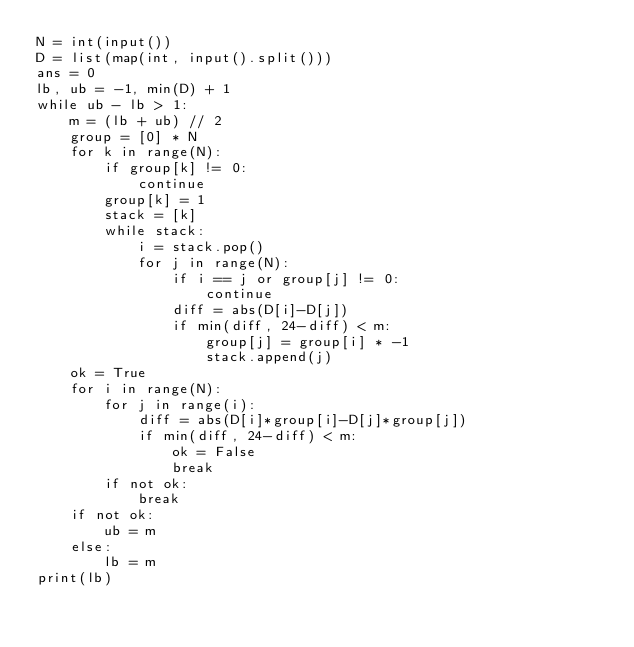<code> <loc_0><loc_0><loc_500><loc_500><_Python_>N = int(input())
D = list(map(int, input().split()))
ans = 0
lb, ub = -1, min(D) + 1
while ub - lb > 1:
    m = (lb + ub) // 2
    group = [0] * N
    for k in range(N):
        if group[k] != 0:
            continue
        group[k] = 1
        stack = [k]
        while stack:
            i = stack.pop()
            for j in range(N):
                if i == j or group[j] != 0:
                    continue
                diff = abs(D[i]-D[j])
                if min(diff, 24-diff) < m:
                    group[j] = group[i] * -1
                    stack.append(j)
    ok = True
    for i in range(N):
        for j in range(i):
            diff = abs(D[i]*group[i]-D[j]*group[j])
            if min(diff, 24-diff) < m:
                ok = False
                break
        if not ok:
            break
    if not ok:
        ub = m
    else:
        lb = m
print(lb)</code> 